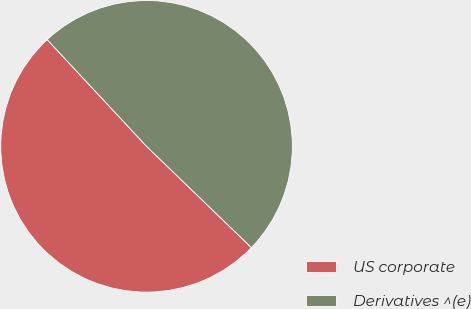<chart> <loc_0><loc_0><loc_500><loc_500><pie_chart><fcel>US corporate<fcel>Derivatives ^(e)<nl><fcel>50.84%<fcel>49.16%<nl></chart> 